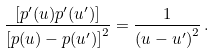Convert formula to latex. <formula><loc_0><loc_0><loc_500><loc_500>\frac { [ p ^ { \prime } ( u ) p ^ { \prime } ( u ^ { \prime } ) ] } { { [ p ( u ) - p ( u ^ { \prime } ) ] } ^ { 2 } } = \frac { 1 } { { ( u - u ^ { \prime } ) } ^ { 2 } } \, .</formula> 